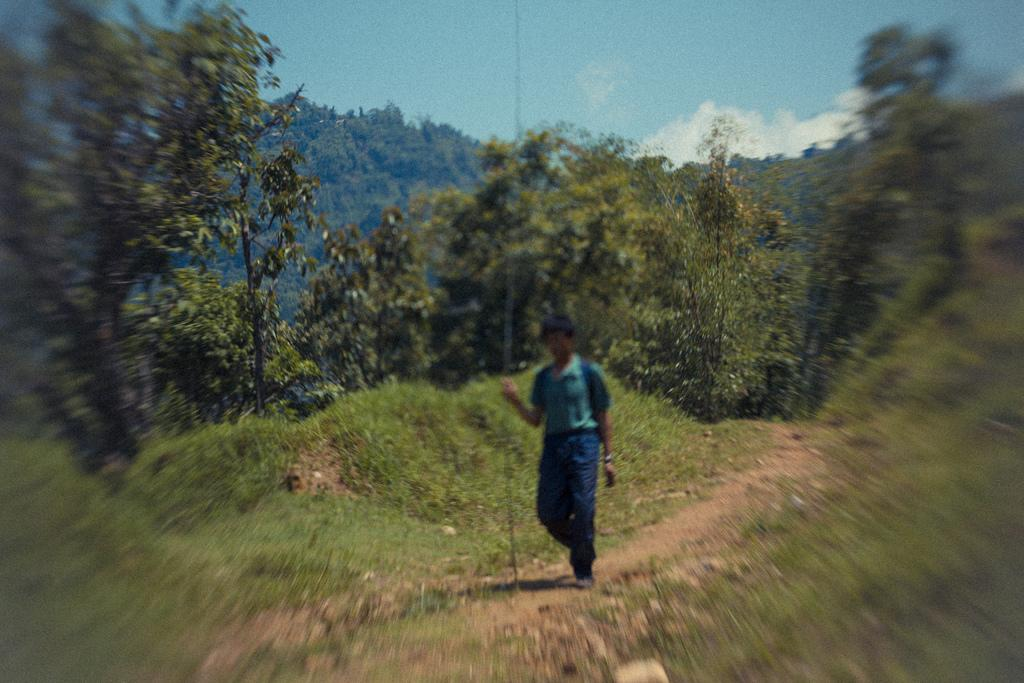What type of vegetation can be seen in the image? There is grass and trees in the image. What is the person in the image doing? There is a person walking in the image. What type of terrain is visible in the image? There are hills in the image. What is visible at the top of the image? The sky is visible at the top of the image. What type of government is represented by the screw in the image? There is no screw present in the image, so it is not possible to determine the type of government represented. 